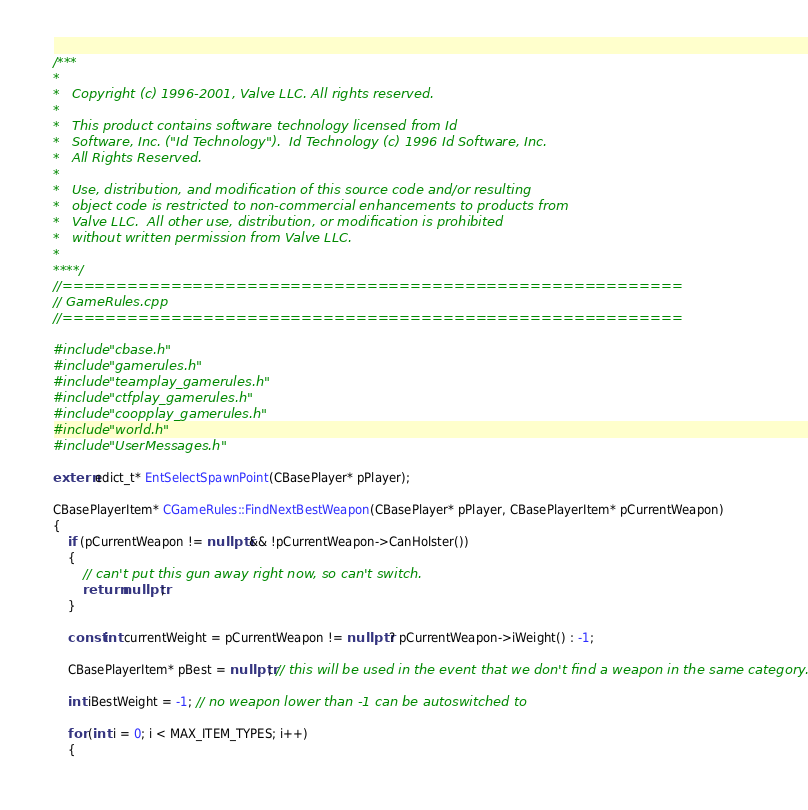<code> <loc_0><loc_0><loc_500><loc_500><_C++_>/***
*
*	Copyright (c) 1996-2001, Valve LLC. All rights reserved.
*
*	This product contains software technology licensed from Id
*	Software, Inc. ("Id Technology").  Id Technology (c) 1996 Id Software, Inc.
*	All Rights Reserved.
*
*   Use, distribution, and modification of this source code and/or resulting
*   object code is restricted to non-commercial enhancements to products from
*   Valve LLC.  All other use, distribution, or modification is prohibited
*   without written permission from Valve LLC.
*
****/
//=========================================================
// GameRules.cpp
//=========================================================

#include "cbase.h"
#include "gamerules.h"
#include "teamplay_gamerules.h"
#include "ctfplay_gamerules.h"
#include "coopplay_gamerules.h"
#include "world.h"
#include "UserMessages.h"

extern edict_t* EntSelectSpawnPoint(CBasePlayer* pPlayer);

CBasePlayerItem* CGameRules::FindNextBestWeapon(CBasePlayer* pPlayer, CBasePlayerItem* pCurrentWeapon)
{
	if (pCurrentWeapon != nullptr && !pCurrentWeapon->CanHolster())
	{
		// can't put this gun away right now, so can't switch.
		return nullptr;
	}

	const int currentWeight = pCurrentWeapon != nullptr ? pCurrentWeapon->iWeight() : -1;

	CBasePlayerItem* pBest = nullptr; // this will be used in the event that we don't find a weapon in the same category.

	int iBestWeight = -1; // no weapon lower than -1 can be autoswitched to

	for (int i = 0; i < MAX_ITEM_TYPES; i++)
	{</code> 